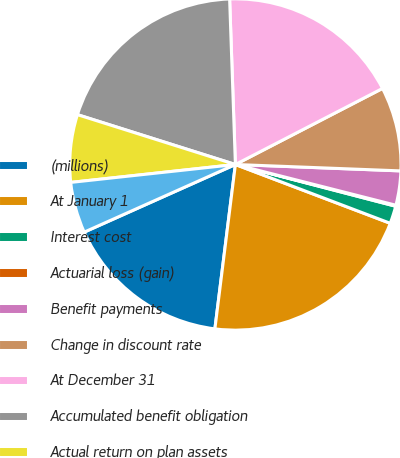Convert chart. <chart><loc_0><loc_0><loc_500><loc_500><pie_chart><fcel>(millions)<fcel>At January 1<fcel>Interest cost<fcel>Actuarial loss (gain)<fcel>Benefit payments<fcel>Change in discount rate<fcel>At December 31<fcel>Accumulated benefit obligation<fcel>Actual return on plan assets<fcel>Employer contributions<nl><fcel>16.33%<fcel>21.2%<fcel>1.72%<fcel>0.1%<fcel>3.34%<fcel>8.21%<fcel>17.96%<fcel>19.58%<fcel>6.59%<fcel>4.97%<nl></chart> 